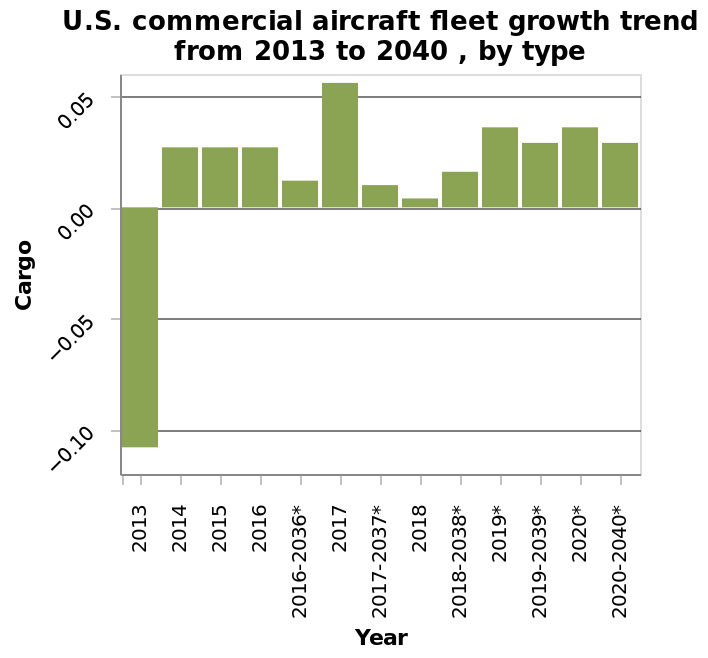<image>
What is the range of the Cargo values on the y-axis? The range of the Cargo values on the y-axis is from -0.10 to 0.05. Can you draw any conclusions about the performance of individual years? No, you cannot draw any conclusions about the performance of individual years based on the given description. What is the title of the bar diagram? The title of the bar diagram is "U.S. commercial aircraft fleet growth trend from 2013 to 2040, by type." Which year had the lowest performance according to the figure? According to the figure, 2013 had the lowest performance. 